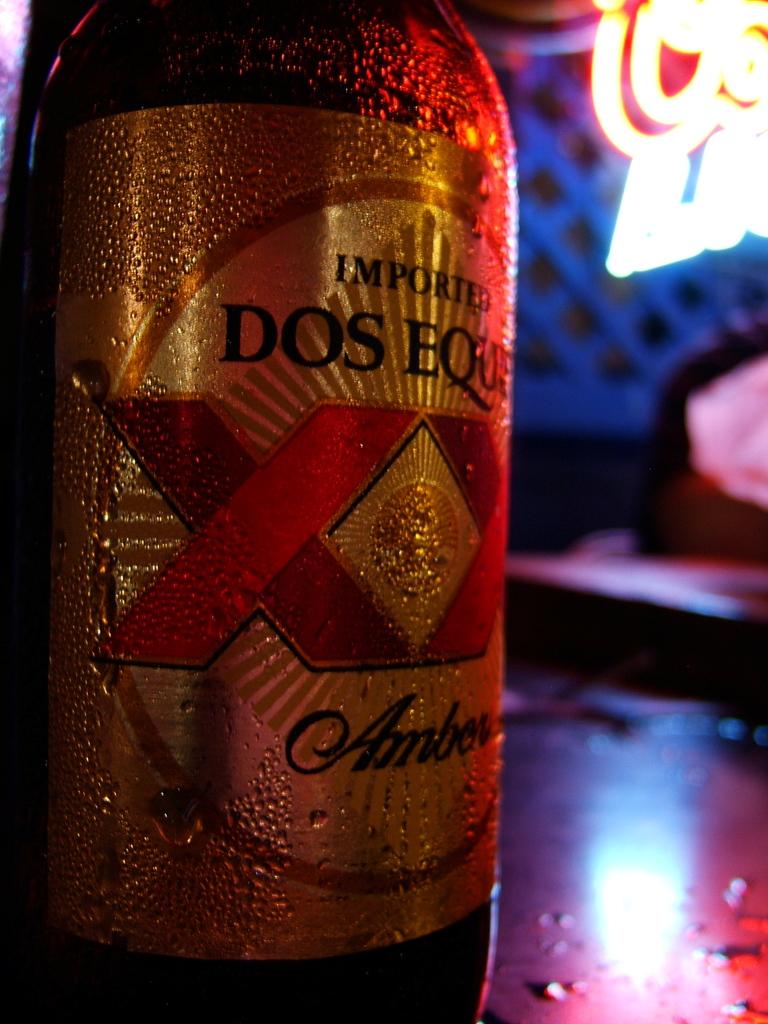What is the name on this beer?
Provide a succinct answer. Dos equis. Is the beer imported?
Keep it short and to the point. Yes. 